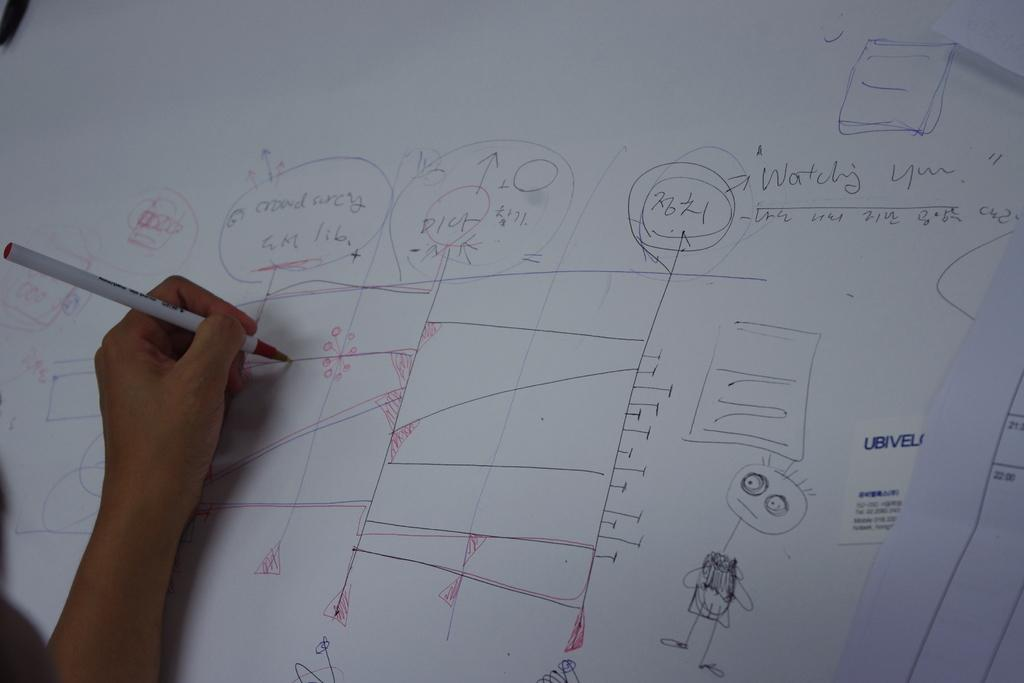<image>
Create a compact narrative representing the image presented. A hand writes on a page that has drawings, lines, and phrases such as "watching you." 